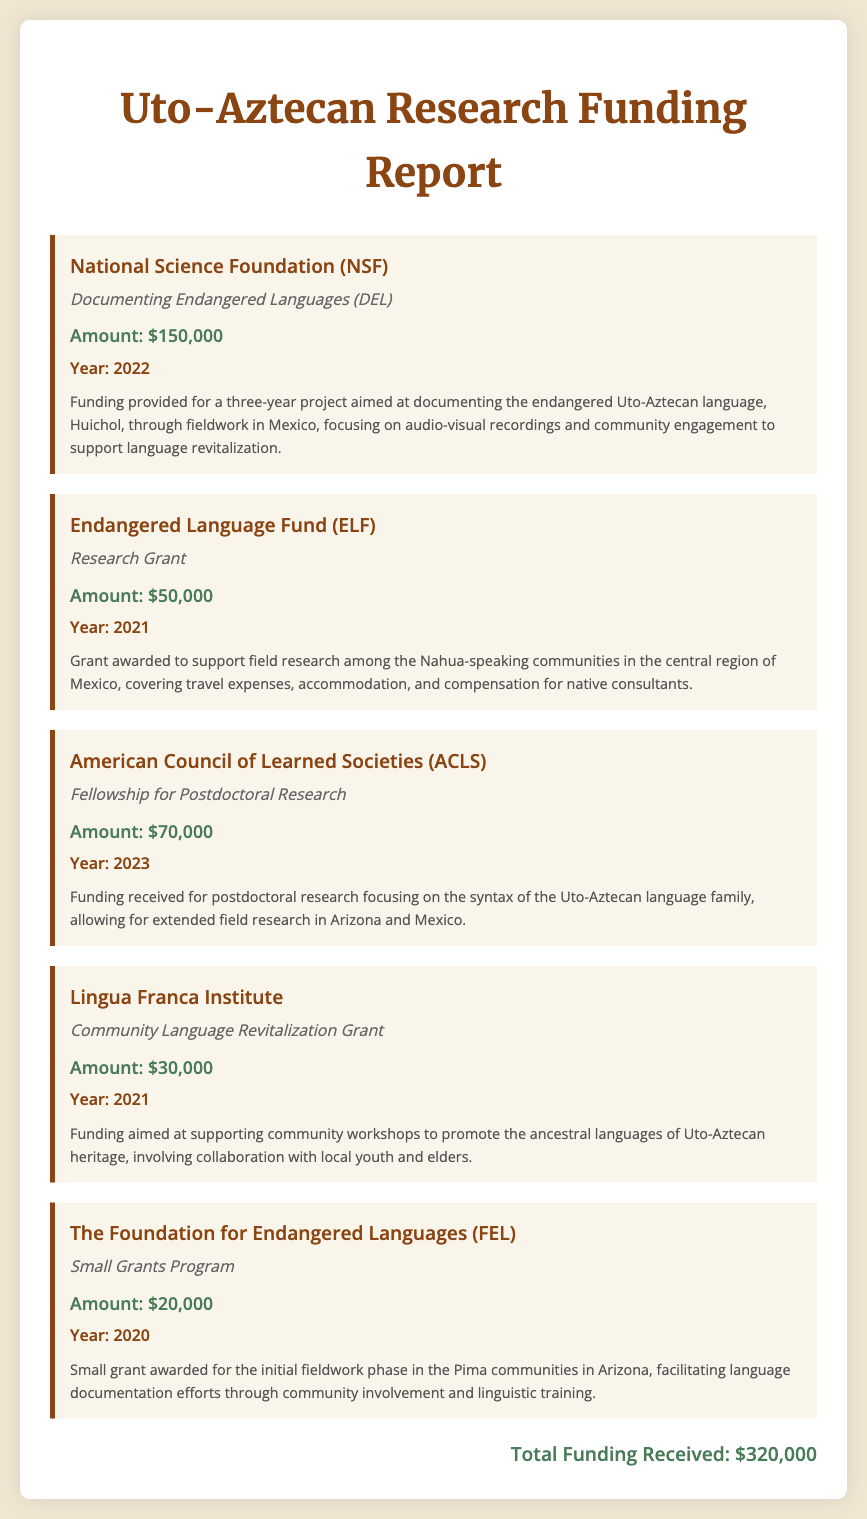What is the total funding received? The total funding received is clearly stated at the end of the document as the sum of all individual funding amounts.
Answer: $320,000 Which institution provided funding for the Huichol language project? The document specifies that the National Science Foundation (NSF) funded the project aimed at documenting the Huichol language.
Answer: National Science Foundation (NSF) What year was the Research Grant from the Endangered Language Fund awarded? The funding report indicates the year for the Endangered Language Fund (ELF) grant was 2021.
Answer: 2021 How much funding was received from the American Council of Learned Societies? The document lists the funding amount received from ACLS for postdoctoral research.
Answer: $70,000 What was the purpose of the grant from the Lingua Franca Institute? The description in the funding report reflects the grant's purpose to support community workshops for language revitalization.
Answer: Community workshops for language revitalization Which funding program supported initial fieldwork in the Pima communities? The funding report specifies that the small grant from The Foundation for Endangered Languages (FEL) was for initial fieldwork in the Pima communities.
Answer: Small Grants Program What was the total amount funded by the Endangered Language Fund? The document provides the specific funding amount allocated by the Endangered Language Fund for its Research Grant.
Answer: $50,000 In which year was funding awarded for the community language revitalization grant? The document records that the grant for community language revitalization was awarded in 2021.
Answer: 2021 